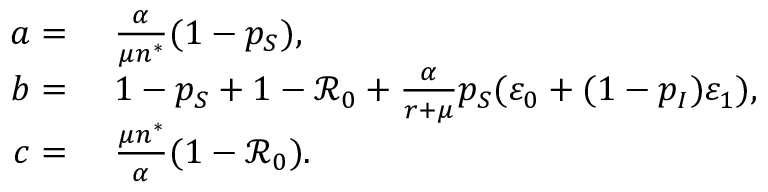<formula> <loc_0><loc_0><loc_500><loc_500>\begin{array} { r l } { a = } & { \frac { \alpha } { \mu n ^ { * } } ( 1 - p _ { S } ) , } \\ { b = } & { 1 - p _ { S } + 1 - \mathcal { R } _ { 0 } + \frac { \alpha } { r + \mu } p _ { S } ( \varepsilon _ { 0 } + ( 1 - p _ { I } ) \varepsilon _ { 1 } ) , } \\ { c = } & { \frac { \mu n ^ { * } } { \alpha } ( 1 - \mathcal { R } _ { 0 } ) . } \end{array}</formula> 